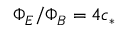<formula> <loc_0><loc_0><loc_500><loc_500>\Phi _ { E } / \Phi _ { B } = 4 c _ { * }</formula> 